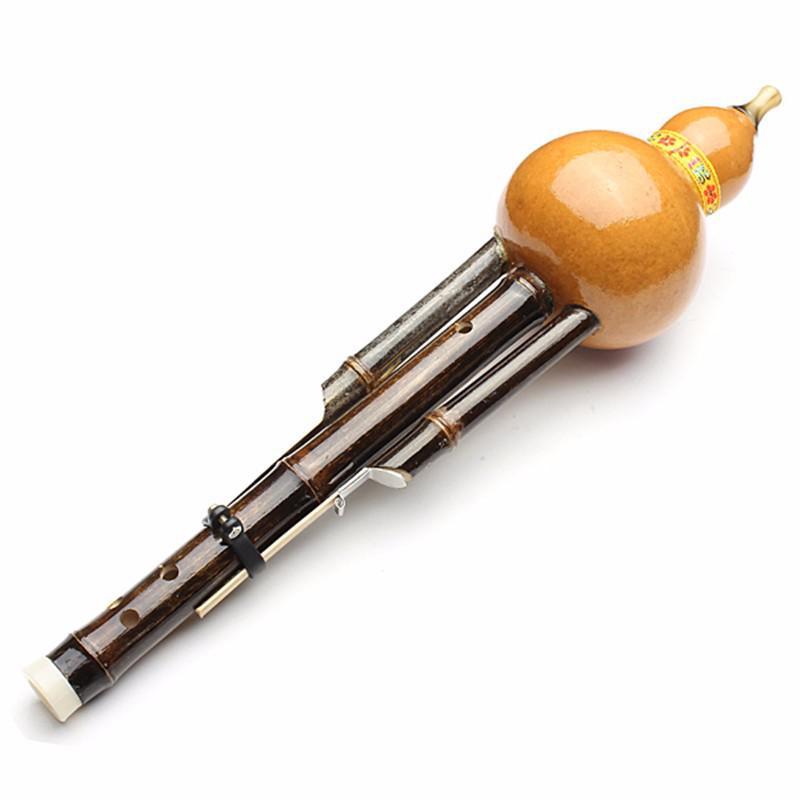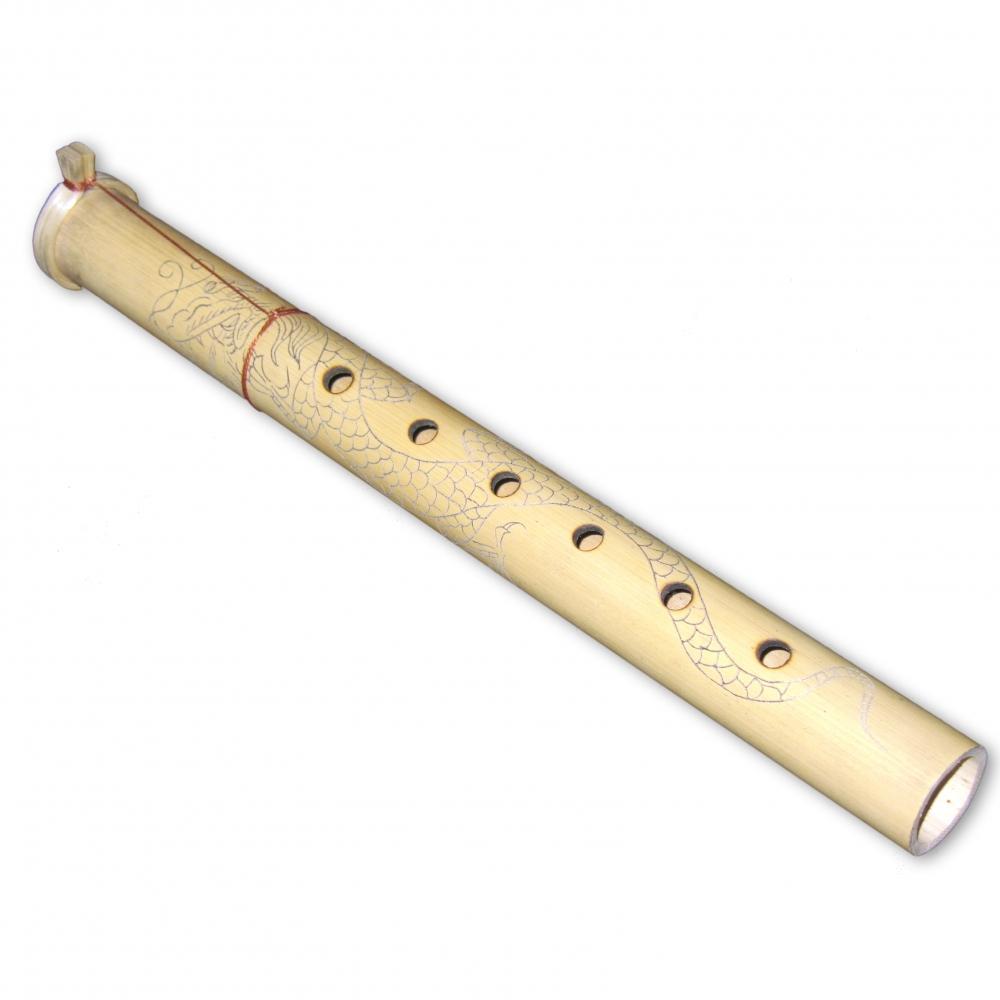The first image is the image on the left, the second image is the image on the right. Considering the images on both sides, is "There are two instruments." valid? Answer yes or no. Yes. The first image is the image on the left, the second image is the image on the right. Examine the images to the left and right. Is the description "There are exactly two flutes." accurate? Answer yes or no. Yes. 